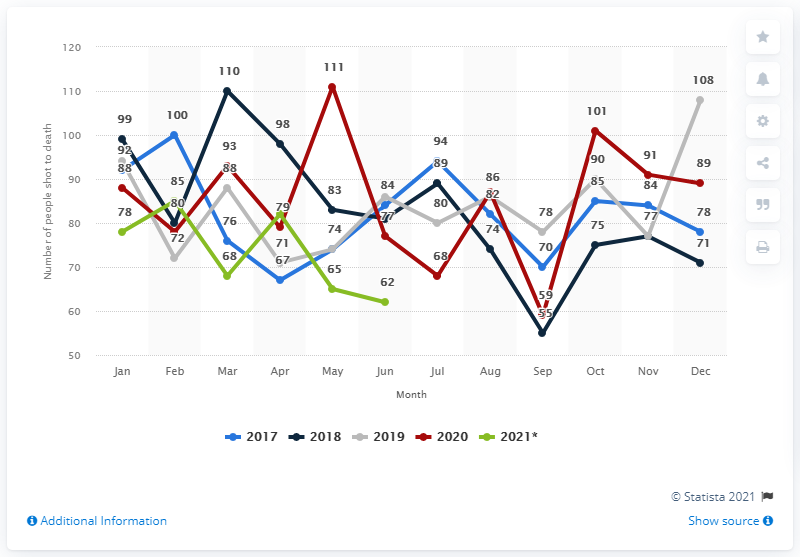Point out several critical features in this image. In June 2021, 62 people were killed by police. 